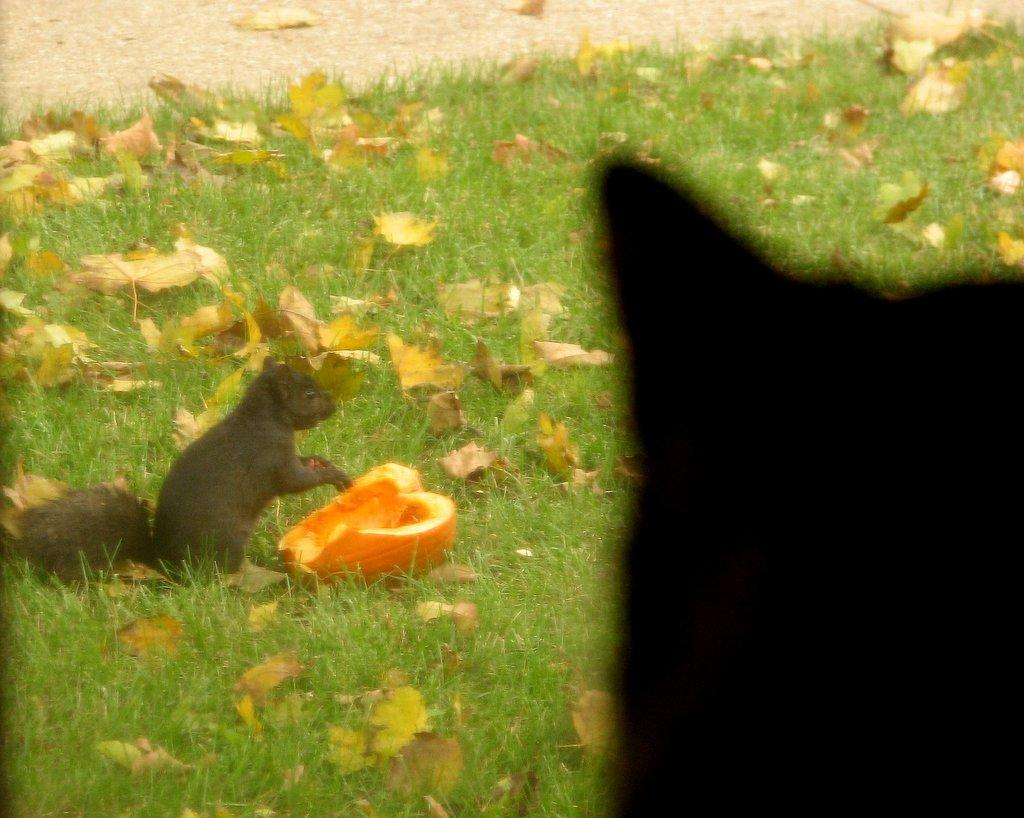What type of vegetation can be seen in the image? There is grass in the image. What other natural elements are present in the image? There are leaves in the image. What animal can be seen on the left side of the image? There is a squirrel on the left side of the image. What object is located in the middle of the image? There is a pumpkin in the middle of the image. What type of tax does the farmer pay for the pumpkin in the image? There is no farmer or tax mentioned in the image; it only features a squirrel, grass, leaves, and a pumpkin. 